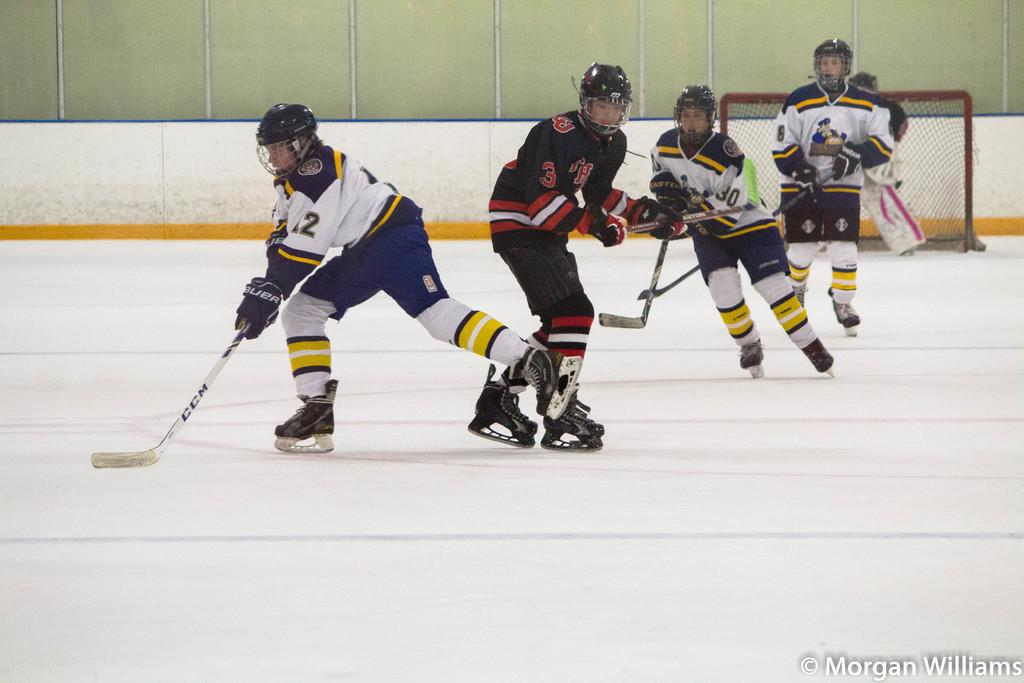How many people are playing ice hockey in the image? There are five men in the image playing ice hockey. What sport are the men engaged in? The men are playing ice hockey. What can be seen in the background of the image? There is a wall in the background of the image. What type of connection can be seen between the men in the image? There is no specific connection between the men mentioned in the image; they are simply playing ice hockey together. 